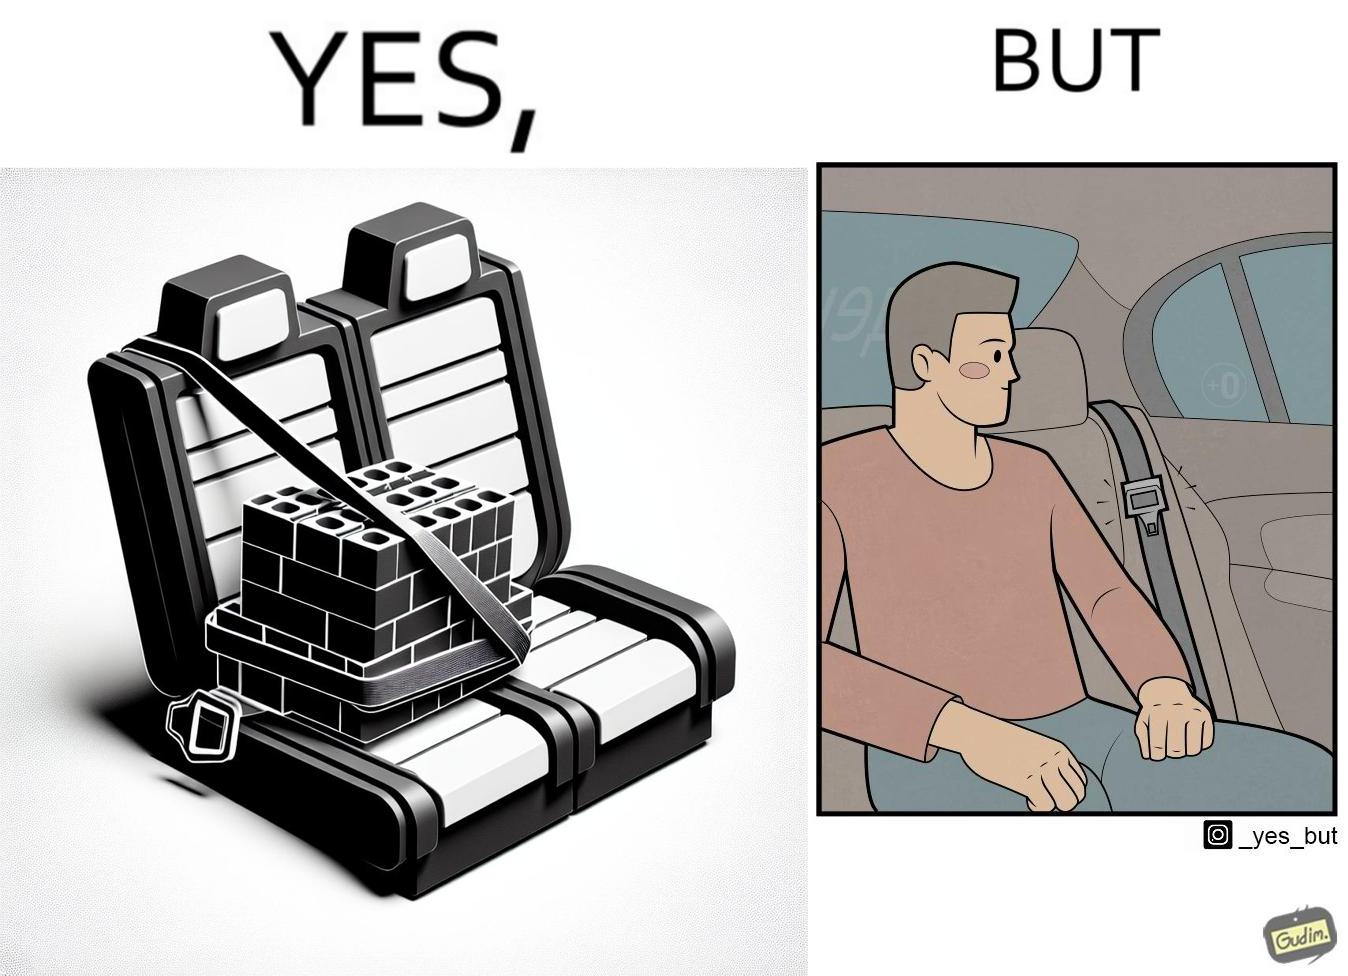Is this a satirical image? Yes, this image is satirical. 